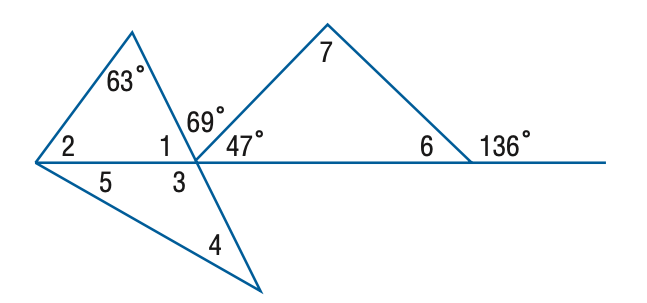Answer the mathemtical geometry problem and directly provide the correct option letter.
Question: Find the measure of \angle 2 if m \angle 4 = m \angle 5.
Choices: A: 47 B: 53 C: 63 D: 64 B 